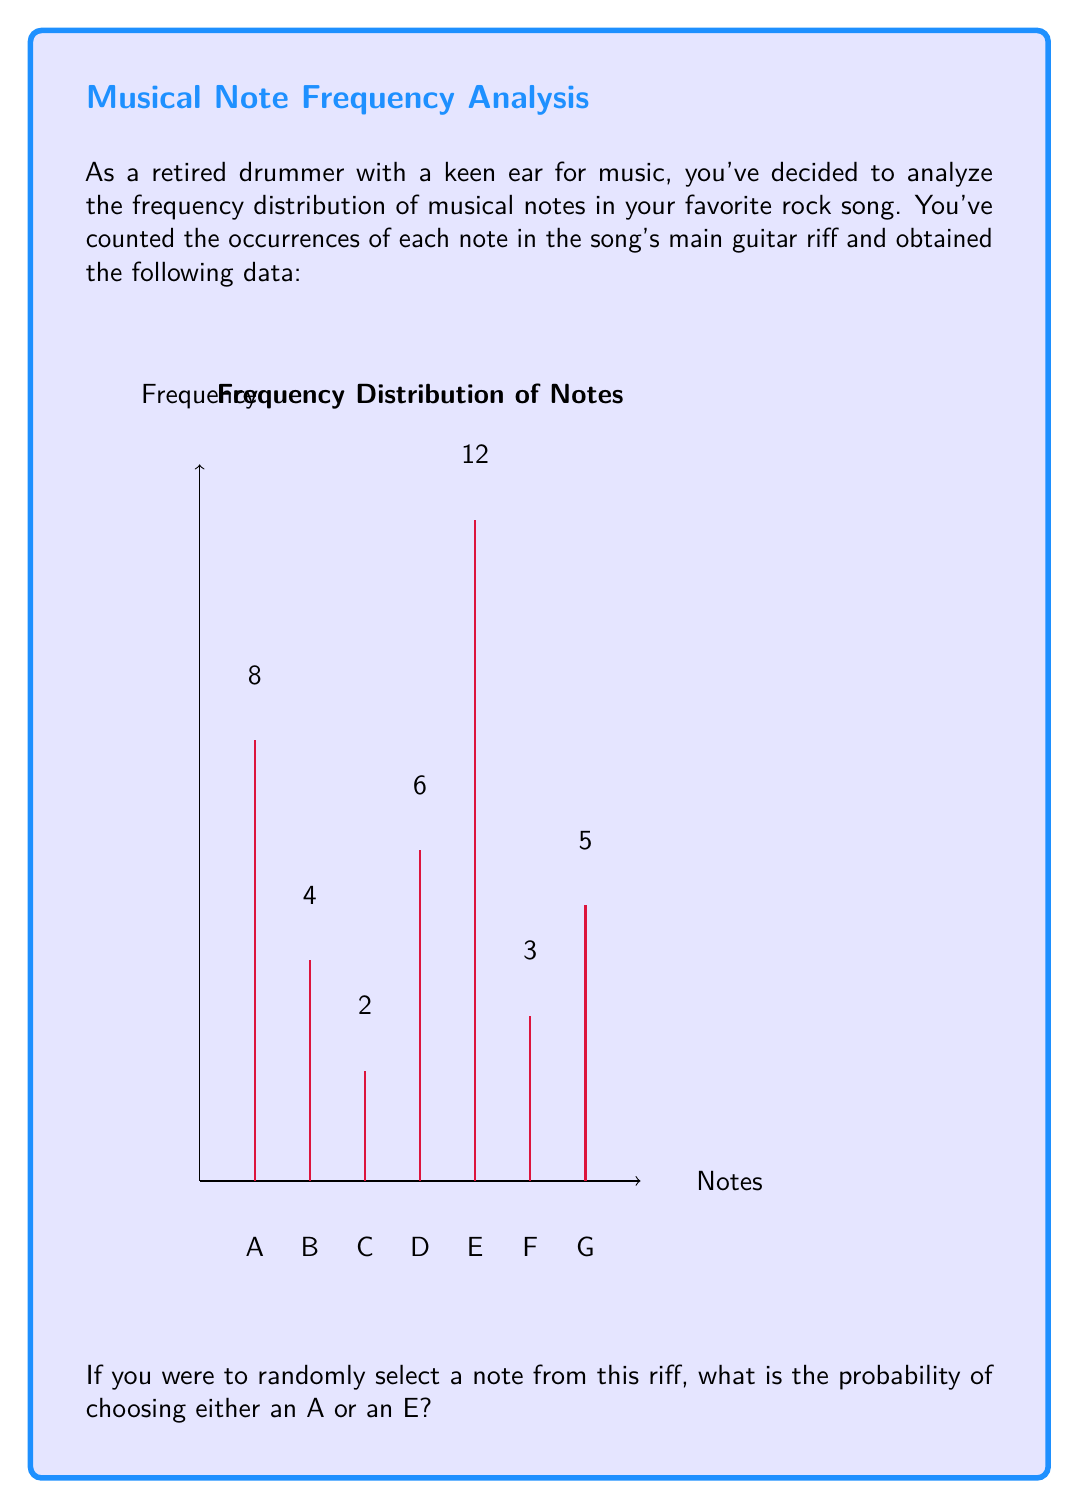Solve this math problem. Let's approach this step-by-step:

1) First, we need to calculate the total number of notes in the riff. We can do this by summing up all the frequencies:

   $$ \text{Total notes} = 8 + 4 + 2 + 6 + 12 + 3 + 5 = 40 $$

2) Now, we're interested in the probability of selecting either an A or an E. In probability theory, this is an "or" situation, so we add the individual probabilities.

3) For note A:
   $$ P(A) = \frac{\text{Frequency of A}}{\text{Total notes}} = \frac{8}{40} = \frac{1}{5} = 0.2 $$

4) For note E:
   $$ P(E) = \frac{\text{Frequency of E}}{\text{Total notes}} = \frac{12}{40} = \frac{3}{10} = 0.3 $$

5) The probability of selecting either A or E is the sum of these probabilities:

   $$ P(A \text{ or } E) = P(A) + P(E) = \frac{1}{5} + \frac{3}{10} = \frac{2}{10} + \frac{3}{10} = \frac{5}{10} = \frac{1}{2} $$

Therefore, the probability of randomly selecting either an A or an E from this riff is $\frac{1}{2}$ or 0.5 or 50%.
Answer: $\frac{1}{2}$ 